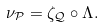Convert formula to latex. <formula><loc_0><loc_0><loc_500><loc_500>\nu _ { \mathcal { P } } = \zeta _ { \mathcal { Q } } \circ \Lambda .</formula> 